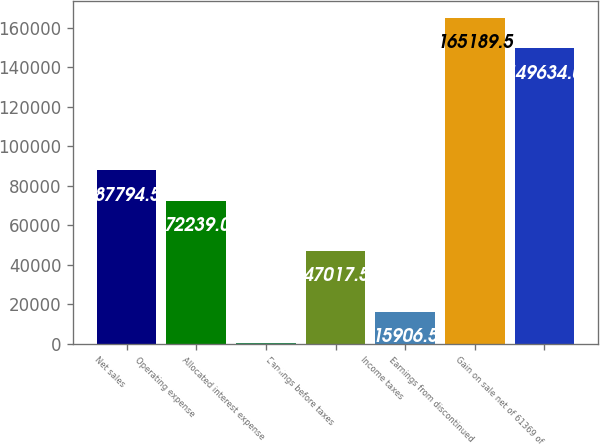<chart> <loc_0><loc_0><loc_500><loc_500><bar_chart><fcel>Net sales<fcel>Operating expense<fcel>Allocated interest expense<fcel>Earnings before taxes<fcel>Income taxes<fcel>Earnings from discontinued<fcel>Gain on sale net of 61369 of<nl><fcel>87794.5<fcel>72239<fcel>351<fcel>47017.5<fcel>15906.5<fcel>165190<fcel>149634<nl></chart> 